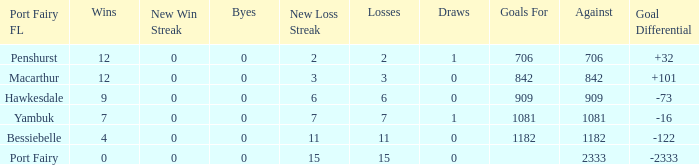How many draws when the Port Fairy FL is Hawkesdale and there are more than 9 wins? None. 